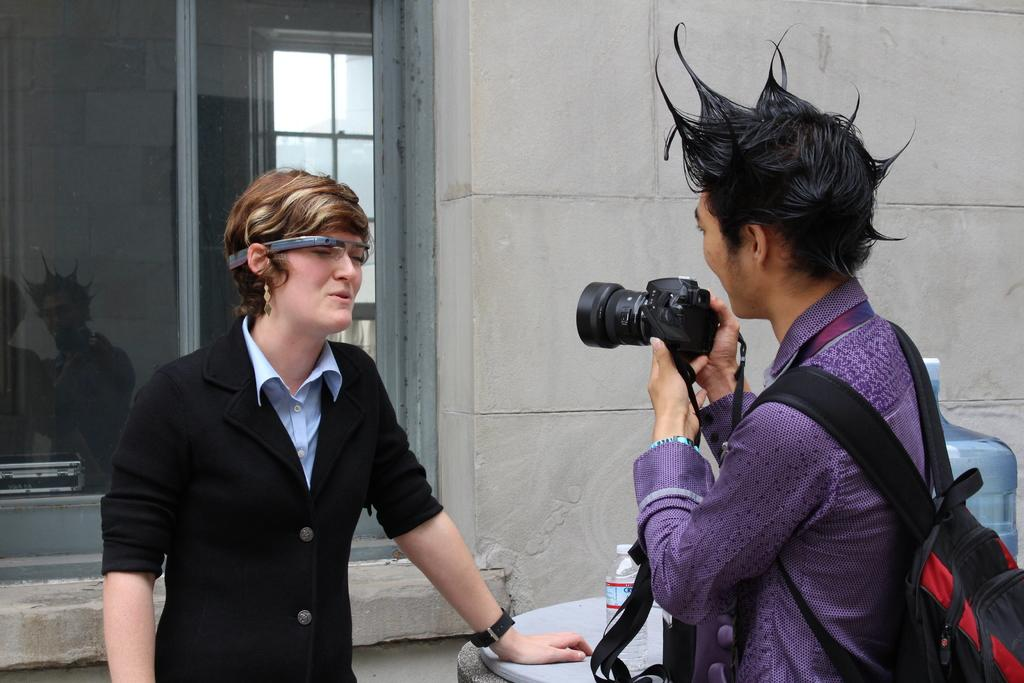What can be seen in the background of the image? There is a wall and a window in the background of the image. Who is present in the image? There is a man in the image. What is the man wearing? The man is wearing a backpack. What is the man holding? The man is holding a camera. What is the man doing with the camera? The man is recording something. What else can be seen in the image? There is a water bottle in the image. What religion is the man practicing in the image? There is no indication of the man's religion in the image. What type of voyage is the man embarking on in the image? There is no indication of a voyage in the image; the man is simply holding a camera and recording something. 